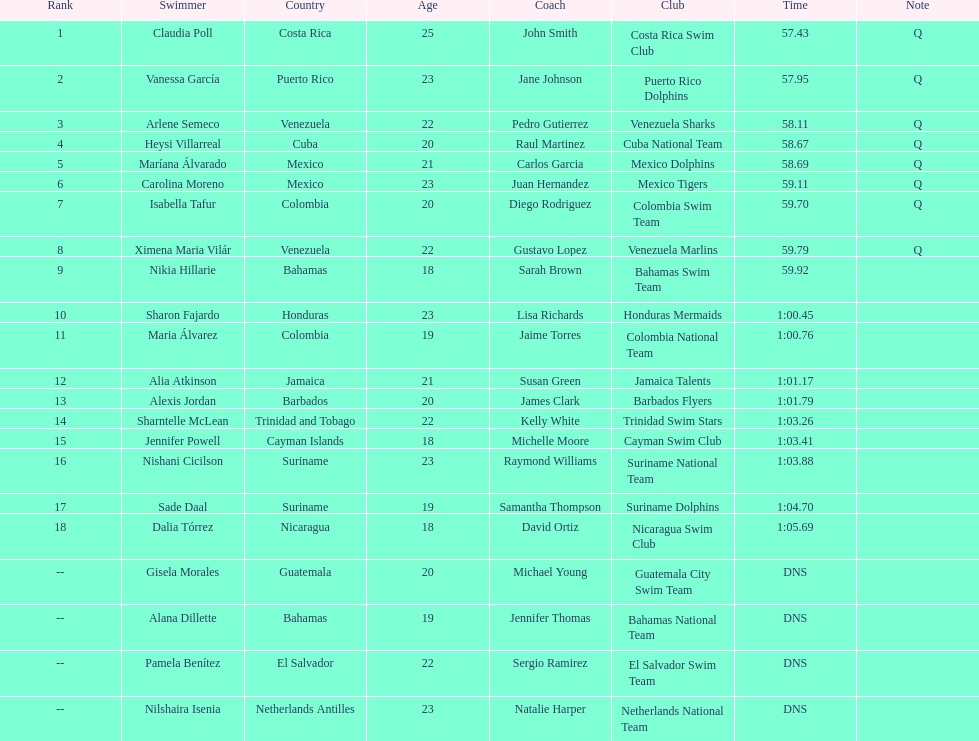What swimmer had the top or first rank? Claudia Poll. 